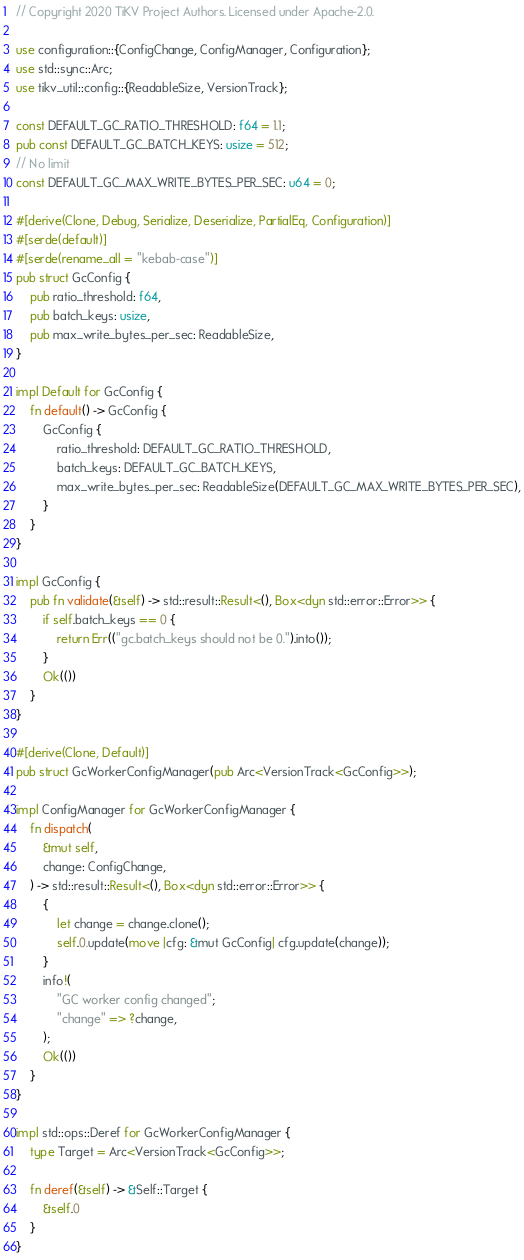Convert code to text. <code><loc_0><loc_0><loc_500><loc_500><_Rust_>// Copyright 2020 TiKV Project Authors. Licensed under Apache-2.0.

use configuration::{ConfigChange, ConfigManager, Configuration};
use std::sync::Arc;
use tikv_util::config::{ReadableSize, VersionTrack};

const DEFAULT_GC_RATIO_THRESHOLD: f64 = 1.1;
pub const DEFAULT_GC_BATCH_KEYS: usize = 512;
// No limit
const DEFAULT_GC_MAX_WRITE_BYTES_PER_SEC: u64 = 0;

#[derive(Clone, Debug, Serialize, Deserialize, PartialEq, Configuration)]
#[serde(default)]
#[serde(rename_all = "kebab-case")]
pub struct GcConfig {
    pub ratio_threshold: f64,
    pub batch_keys: usize,
    pub max_write_bytes_per_sec: ReadableSize,
}

impl Default for GcConfig {
    fn default() -> GcConfig {
        GcConfig {
            ratio_threshold: DEFAULT_GC_RATIO_THRESHOLD,
            batch_keys: DEFAULT_GC_BATCH_KEYS,
            max_write_bytes_per_sec: ReadableSize(DEFAULT_GC_MAX_WRITE_BYTES_PER_SEC),
        }
    }
}

impl GcConfig {
    pub fn validate(&self) -> std::result::Result<(), Box<dyn std::error::Error>> {
        if self.batch_keys == 0 {
            return Err(("gc.batch_keys should not be 0.").into());
        }
        Ok(())
    }
}

#[derive(Clone, Default)]
pub struct GcWorkerConfigManager(pub Arc<VersionTrack<GcConfig>>);

impl ConfigManager for GcWorkerConfigManager {
    fn dispatch(
        &mut self,
        change: ConfigChange,
    ) -> std::result::Result<(), Box<dyn std::error::Error>> {
        {
            let change = change.clone();
            self.0.update(move |cfg: &mut GcConfig| cfg.update(change));
        }
        info!(
            "GC worker config changed";
            "change" => ?change,
        );
        Ok(())
    }
}

impl std::ops::Deref for GcWorkerConfigManager {
    type Target = Arc<VersionTrack<GcConfig>>;

    fn deref(&self) -> &Self::Target {
        &self.0
    }
}
</code> 